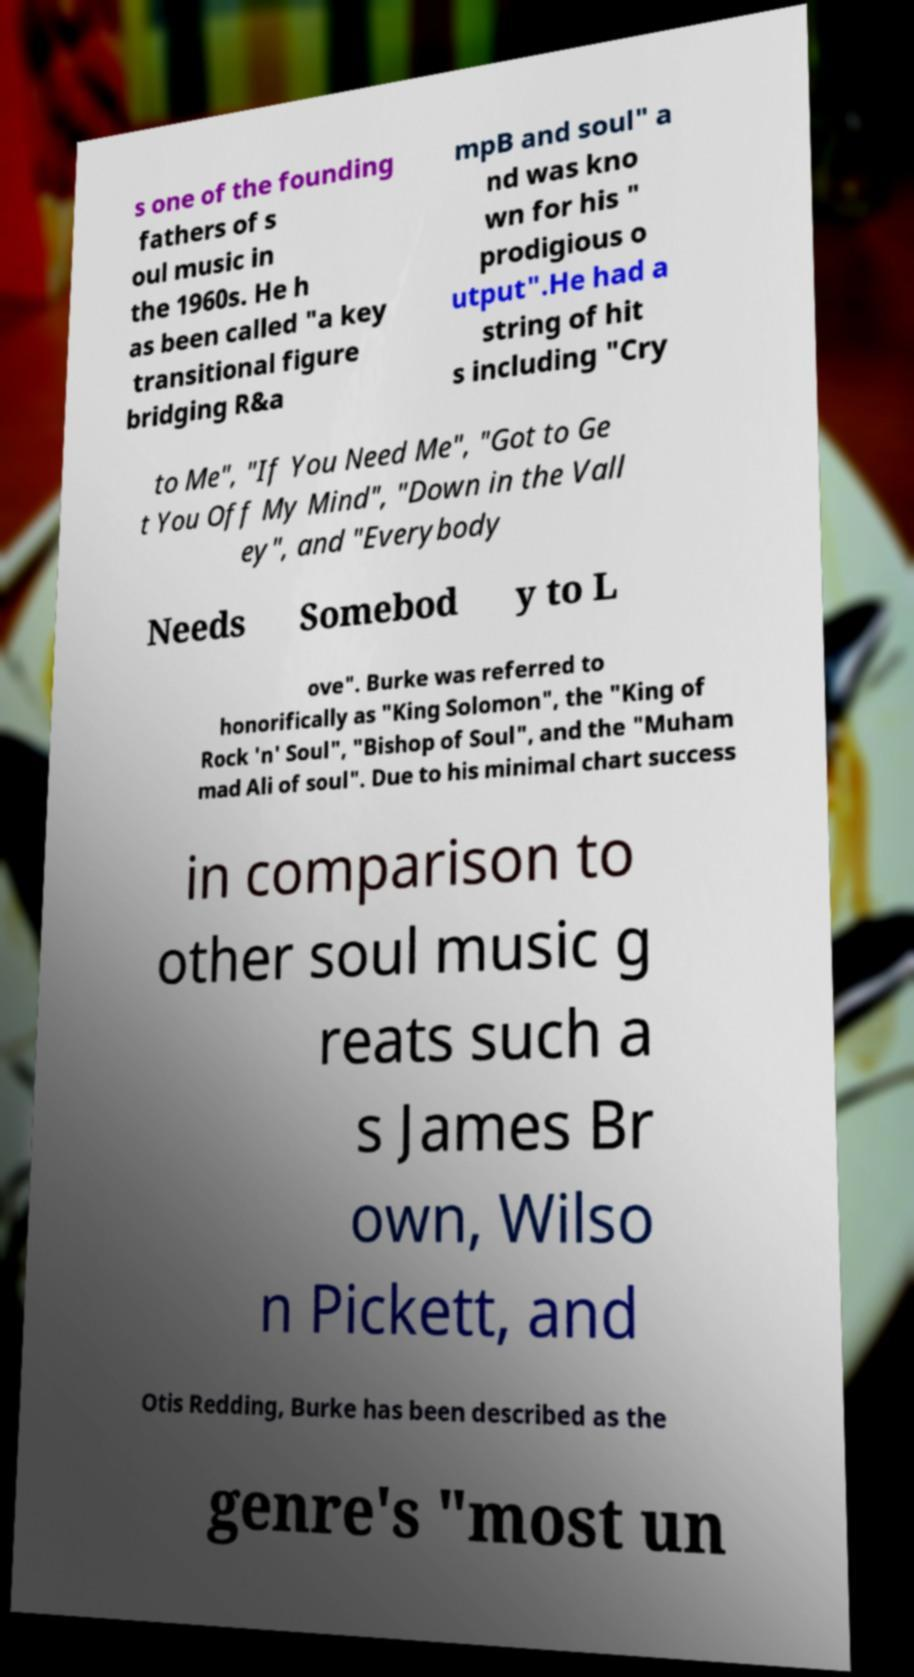Can you accurately transcribe the text from the provided image for me? s one of the founding fathers of s oul music in the 1960s. He h as been called "a key transitional figure bridging R&a mpB and soul" a nd was kno wn for his " prodigious o utput".He had a string of hit s including "Cry to Me", "If You Need Me", "Got to Ge t You Off My Mind", "Down in the Vall ey", and "Everybody Needs Somebod y to L ove". Burke was referred to honorifically as "King Solomon", the "King of Rock 'n' Soul", "Bishop of Soul", and the "Muham mad Ali of soul". Due to his minimal chart success in comparison to other soul music g reats such a s James Br own, Wilso n Pickett, and Otis Redding, Burke has been described as the genre's "most un 